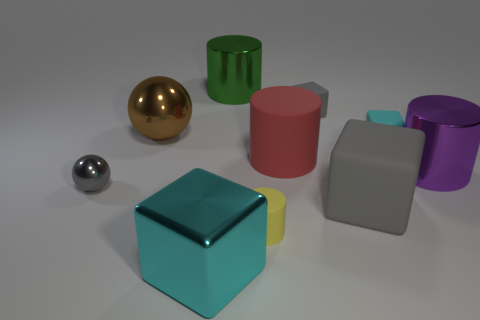Subtract all big rubber cylinders. How many cylinders are left? 3 Subtract all red balls. How many cyan blocks are left? 2 Subtract 2 cylinders. How many cylinders are left? 2 Subtract all yellow cylinders. How many cylinders are left? 3 Subtract all blue cylinders. Subtract all brown blocks. How many cylinders are left? 4 Subtract all cylinders. How many objects are left? 6 Subtract 1 purple cylinders. How many objects are left? 9 Subtract all large cubes. Subtract all gray balls. How many objects are left? 7 Add 8 big gray blocks. How many big gray blocks are left? 9 Add 2 small cyan cylinders. How many small cyan cylinders exist? 2 